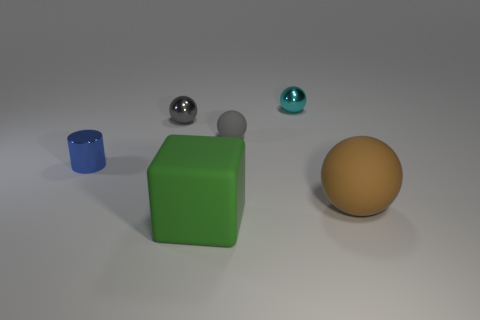Subtract 1 spheres. How many spheres are left? 3 Add 3 small blue matte objects. How many objects exist? 9 Subtract all spheres. How many objects are left? 2 Subtract all tiny purple spheres. Subtract all small gray metal spheres. How many objects are left? 5 Add 4 small cyan spheres. How many small cyan spheres are left? 5 Add 1 big brown matte things. How many big brown matte things exist? 2 Subtract 0 gray cylinders. How many objects are left? 6 